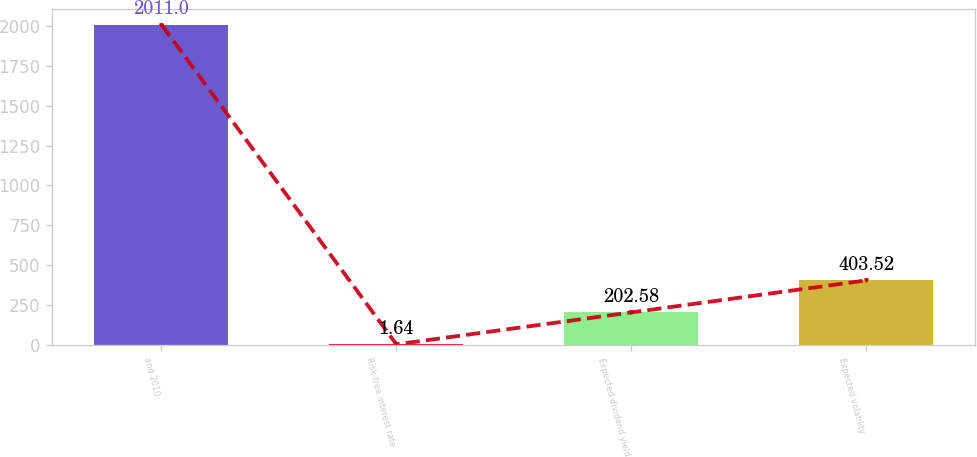Convert chart. <chart><loc_0><loc_0><loc_500><loc_500><bar_chart><fcel>and 2010<fcel>Risk-free interest rate<fcel>Expected dividend yield<fcel>Expected volatility<nl><fcel>2011<fcel>1.64<fcel>202.58<fcel>403.52<nl></chart> 